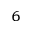<formula> <loc_0><loc_0><loc_500><loc_500>_ { 6 }</formula> 